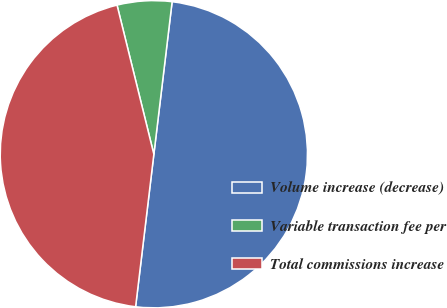<chart> <loc_0><loc_0><loc_500><loc_500><pie_chart><fcel>Volume increase (decrease)<fcel>Variable transaction fee per<fcel>Total commissions increase<nl><fcel>50.0%<fcel>5.75%<fcel>44.25%<nl></chart> 